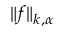<formula> <loc_0><loc_0><loc_500><loc_500>\| f \| _ { k , \alpha }</formula> 